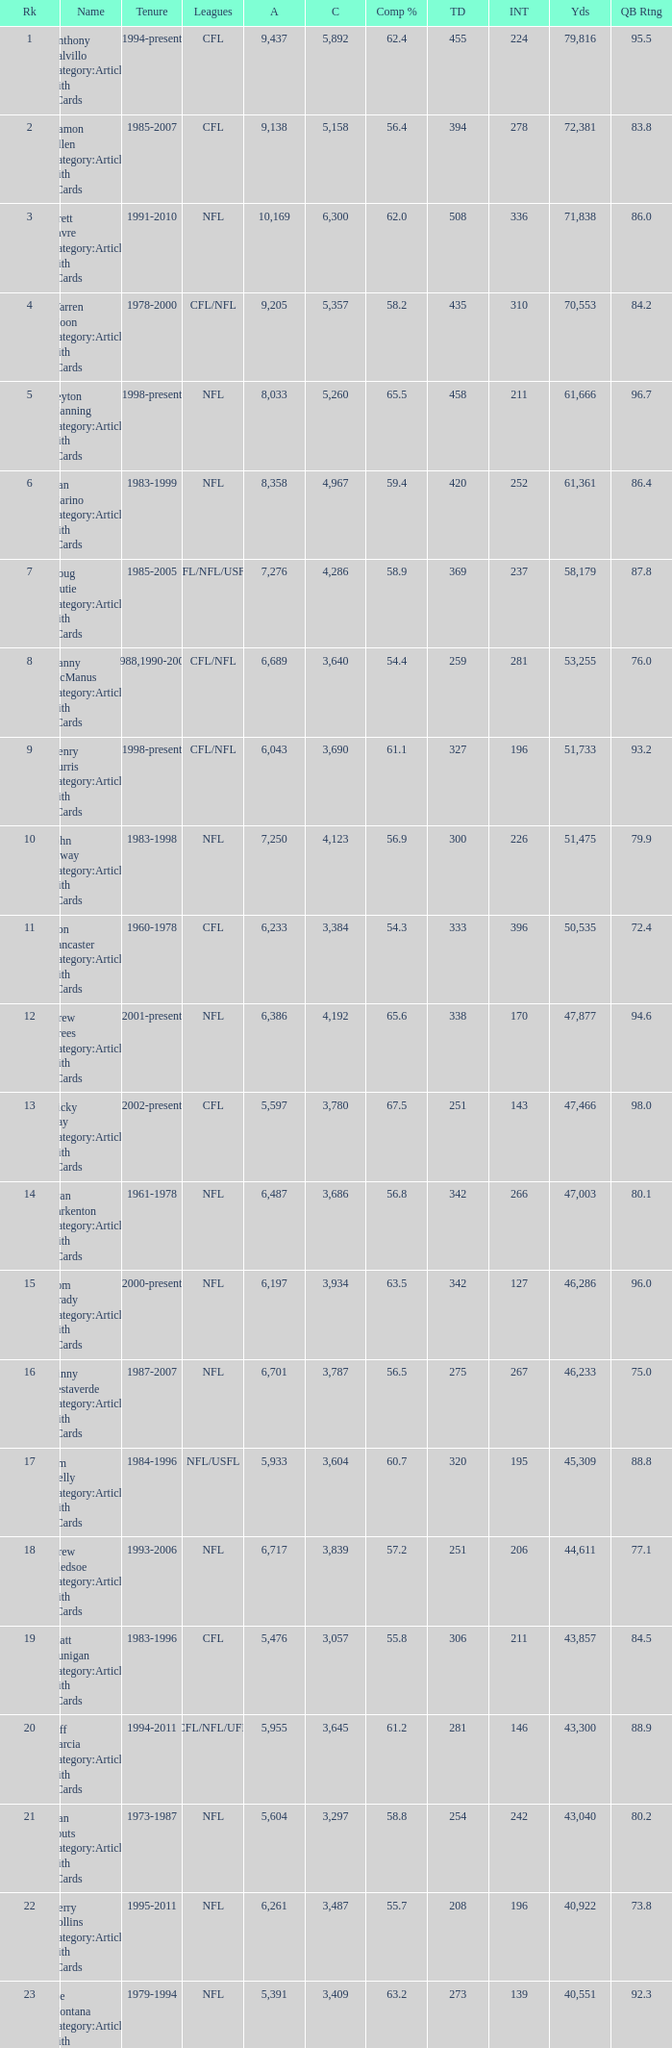When the number of completions exceeds 4,123 and the completion percentage is over 65.6%, what is the rank? None. 